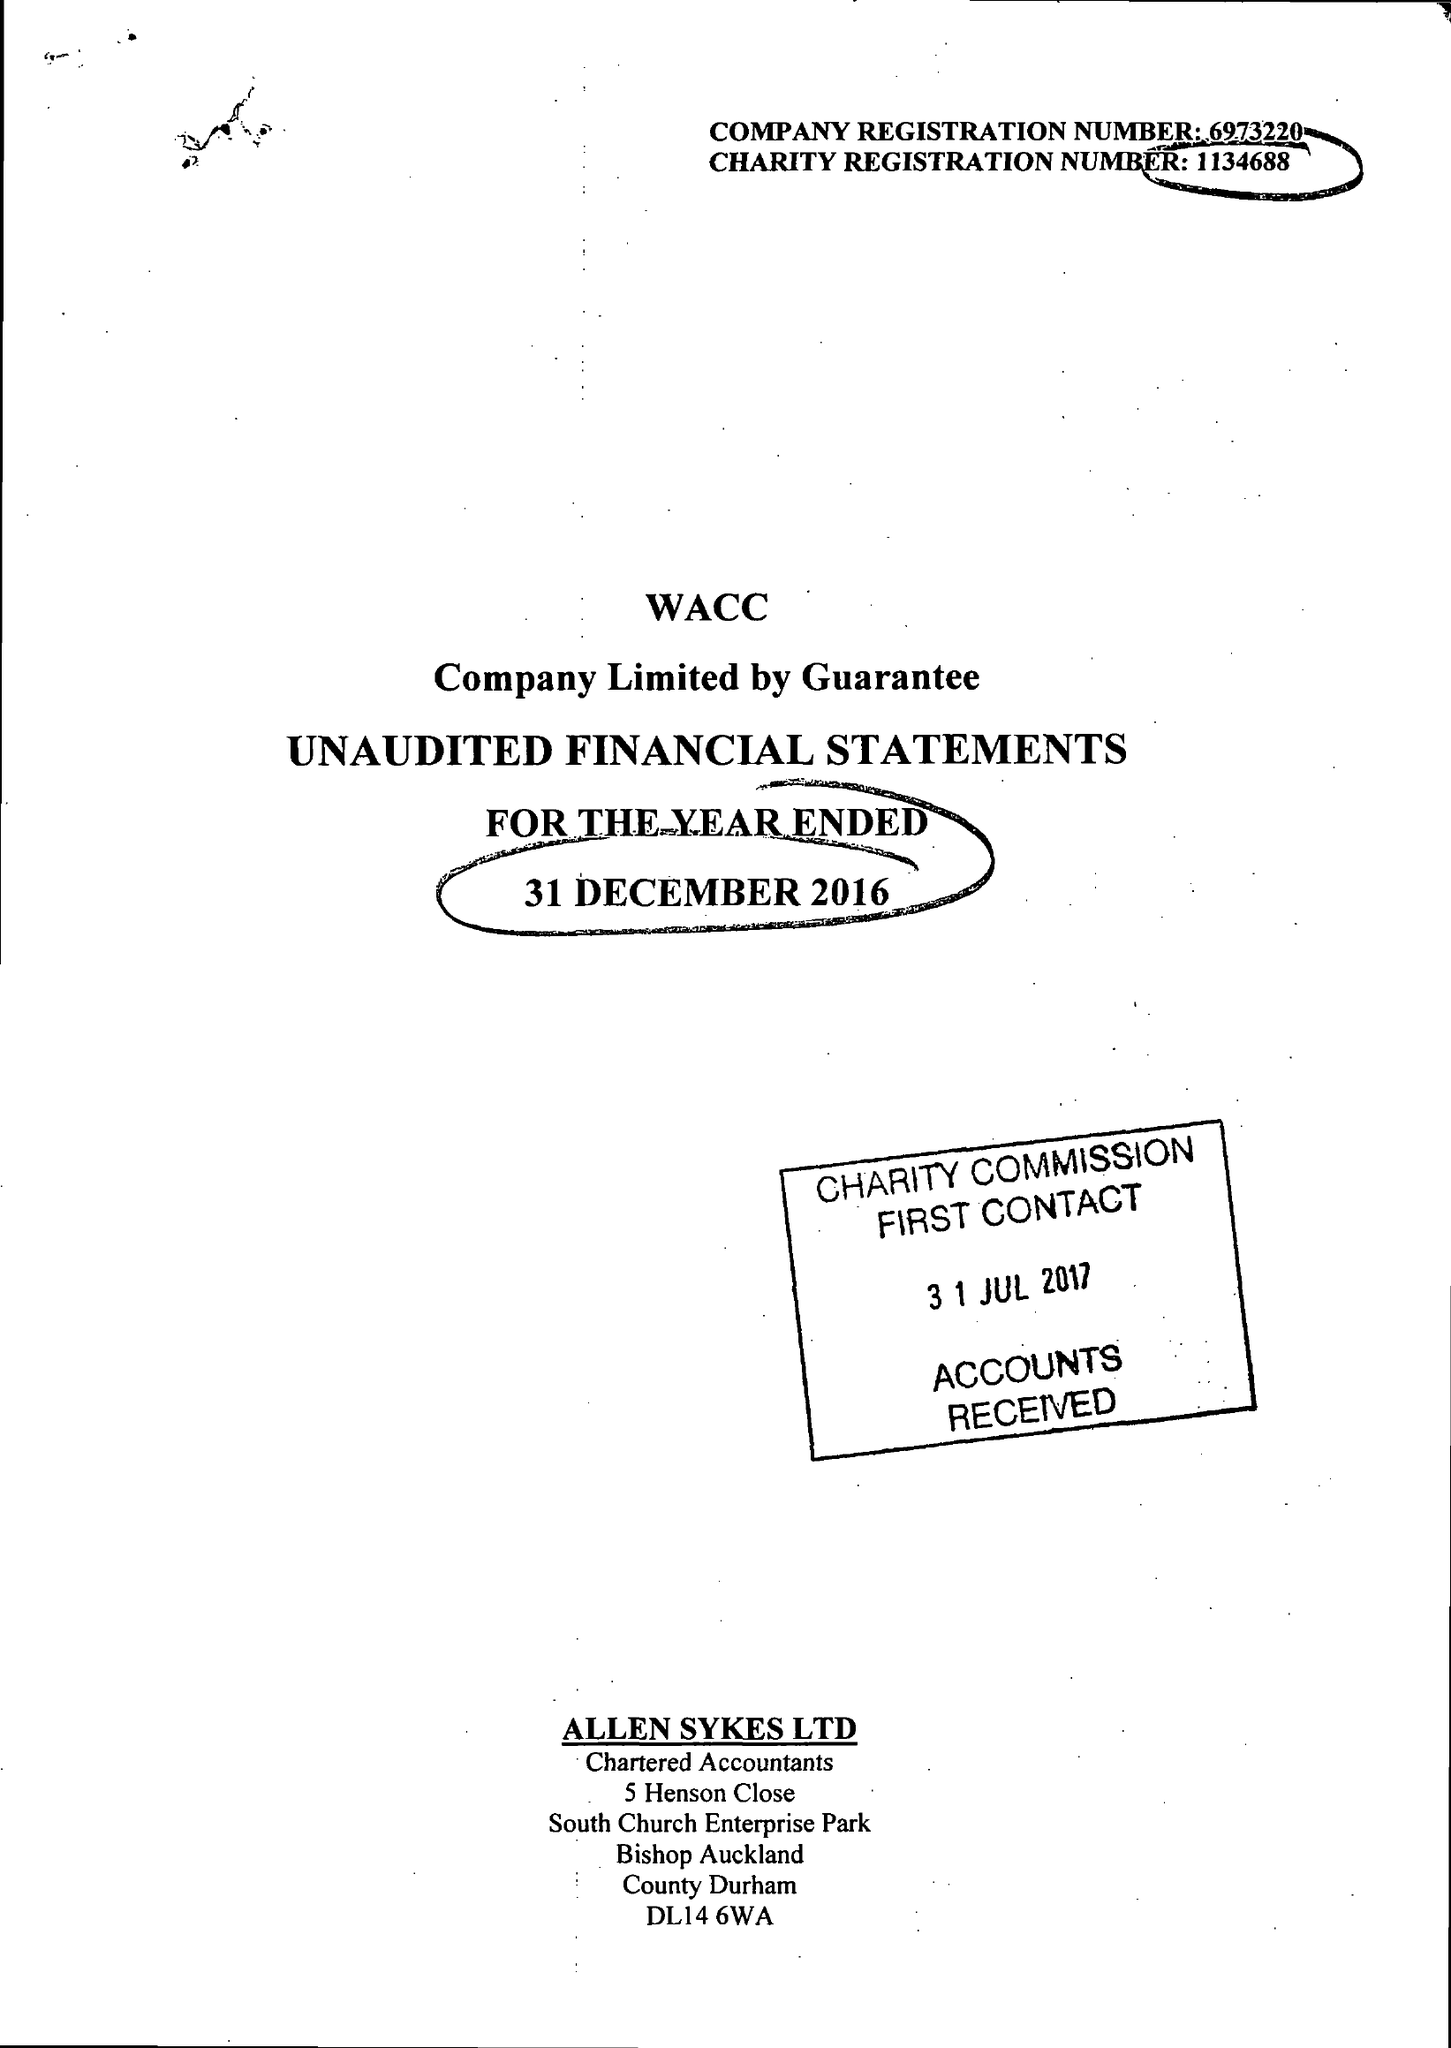What is the value for the income_annually_in_british_pounds?
Answer the question using a single word or phrase. 110580.00 